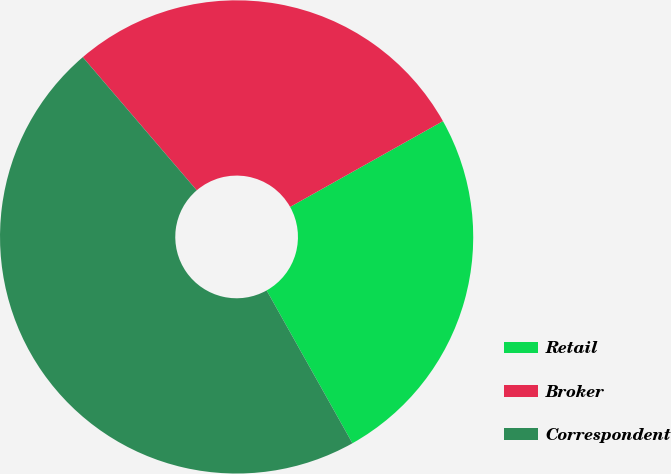<chart> <loc_0><loc_0><loc_500><loc_500><pie_chart><fcel>Retail<fcel>Broker<fcel>Correspondent<nl><fcel>25.0%<fcel>28.13%<fcel>46.88%<nl></chart> 